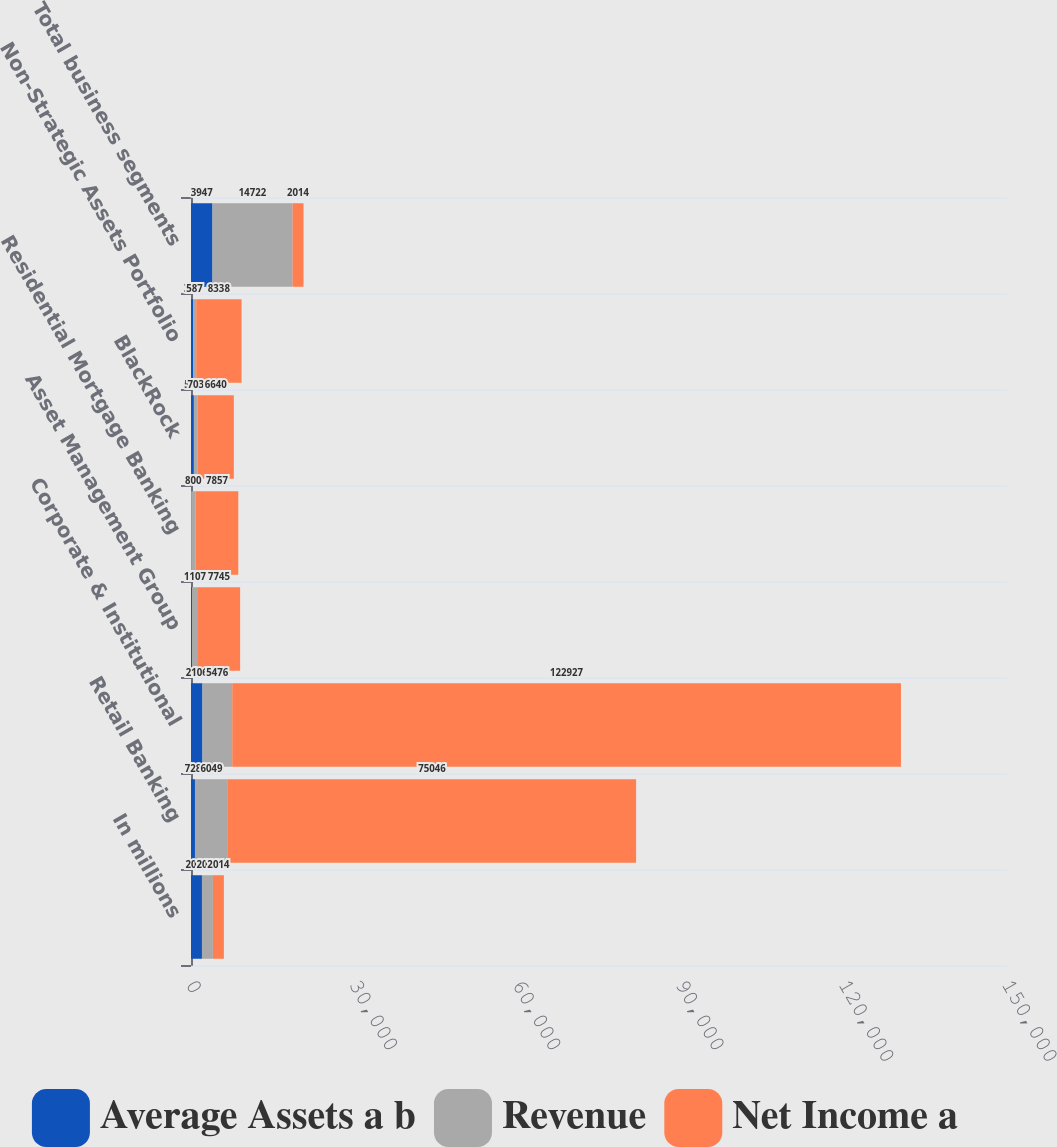<chart> <loc_0><loc_0><loc_500><loc_500><stacked_bar_chart><ecel><fcel>In millions<fcel>Retail Banking<fcel>Corporate & Institutional<fcel>Asset Management Group<fcel>Residential Mortgage Banking<fcel>BlackRock<fcel>Non-Strategic Assets Portfolio<fcel>Total business segments<nl><fcel>Average Assets a b<fcel>2014<fcel>728<fcel>2106<fcel>181<fcel>35<fcel>530<fcel>367<fcel>3947<nl><fcel>Revenue<fcel>2014<fcel>6049<fcel>5476<fcel>1107<fcel>800<fcel>703<fcel>587<fcel>14722<nl><fcel>Net Income a<fcel>2014<fcel>75046<fcel>122927<fcel>7745<fcel>7857<fcel>6640<fcel>8338<fcel>2014<nl></chart> 